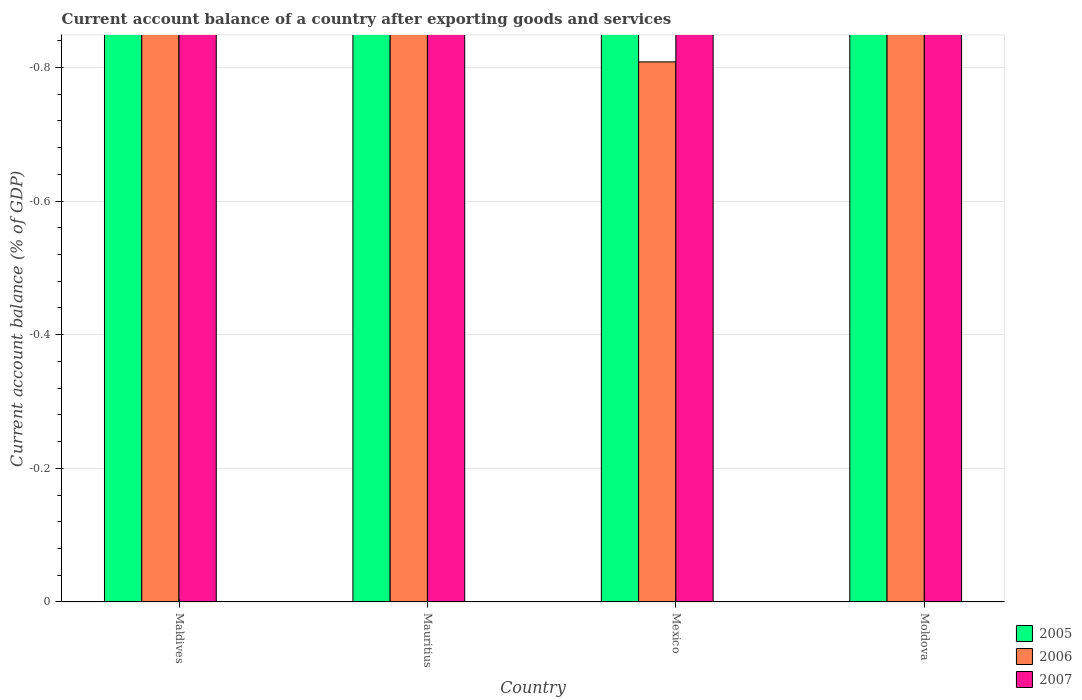How many different coloured bars are there?
Provide a short and direct response. 0. How many bars are there on the 3rd tick from the right?
Your answer should be very brief. 0. What is the label of the 2nd group of bars from the left?
Your answer should be compact. Mauritius. In how many cases, is the number of bars for a given country not equal to the number of legend labels?
Keep it short and to the point. 4. What is the account balance in 2006 in Maldives?
Ensure brevity in your answer.  0. What is the total account balance in 2007 in the graph?
Provide a succinct answer. 0. What is the average account balance in 2006 per country?
Your answer should be very brief. 0. In how many countries, is the account balance in 2006 greater than -0.32 %?
Your answer should be compact. 0. In how many countries, is the account balance in 2007 greater than the average account balance in 2007 taken over all countries?
Give a very brief answer. 0. Is it the case that in every country, the sum of the account balance in 2005 and account balance in 2007 is greater than the account balance in 2006?
Your answer should be compact. No. How many bars are there?
Provide a short and direct response. 0. How many countries are there in the graph?
Give a very brief answer. 4. What is the difference between two consecutive major ticks on the Y-axis?
Provide a succinct answer. 0.2. Where does the legend appear in the graph?
Keep it short and to the point. Bottom right. How are the legend labels stacked?
Offer a very short reply. Vertical. What is the title of the graph?
Ensure brevity in your answer.  Current account balance of a country after exporting goods and services. What is the label or title of the Y-axis?
Your response must be concise. Current account balance (% of GDP). What is the Current account balance (% of GDP) in 2005 in Maldives?
Your answer should be very brief. 0. What is the Current account balance (% of GDP) in 2005 in Mauritius?
Offer a very short reply. 0. What is the Current account balance (% of GDP) in 2006 in Mauritius?
Your response must be concise. 0. What is the Current account balance (% of GDP) of 2005 in Mexico?
Make the answer very short. 0. What is the Current account balance (% of GDP) in 2006 in Mexico?
Give a very brief answer. 0. What is the Current account balance (% of GDP) of 2007 in Mexico?
Your answer should be very brief. 0. What is the Current account balance (% of GDP) in 2005 in Moldova?
Provide a succinct answer. 0. What is the Current account balance (% of GDP) in 2007 in Moldova?
Offer a terse response. 0. What is the total Current account balance (% of GDP) in 2006 in the graph?
Keep it short and to the point. 0. 